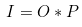<formula> <loc_0><loc_0><loc_500><loc_500>I = O \ast P \\</formula> 